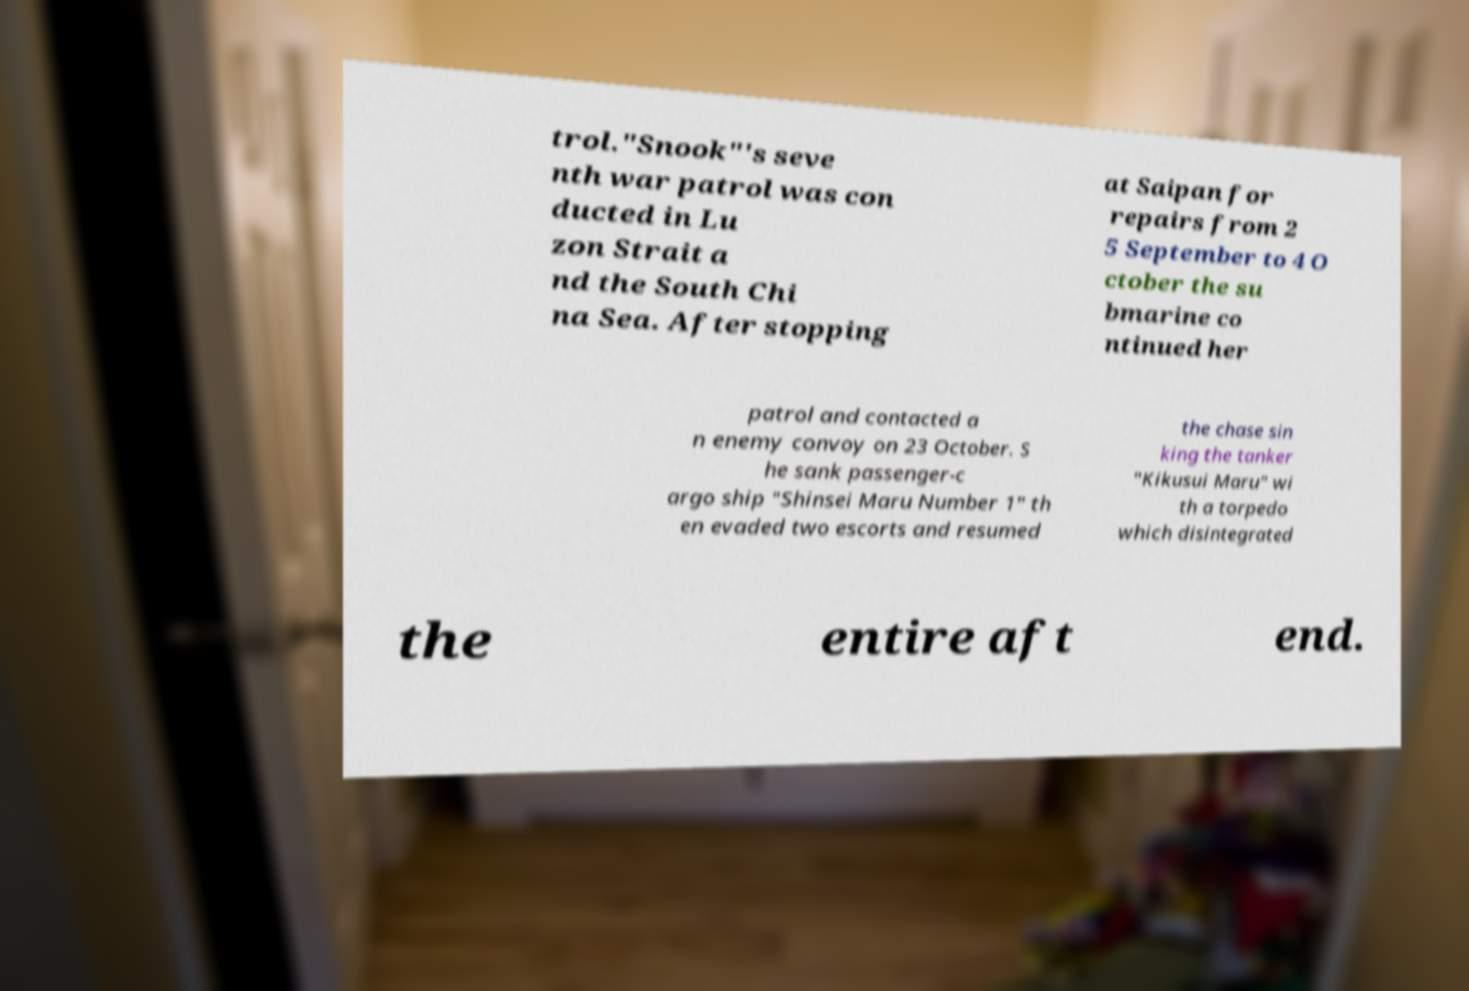Could you extract and type out the text from this image? trol."Snook"'s seve nth war patrol was con ducted in Lu zon Strait a nd the South Chi na Sea. After stopping at Saipan for repairs from 2 5 September to 4 O ctober the su bmarine co ntinued her patrol and contacted a n enemy convoy on 23 October. S he sank passenger-c argo ship "Shinsei Maru Number 1" th en evaded two escorts and resumed the chase sin king the tanker "Kikusui Maru" wi th a torpedo which disintegrated the entire aft end. 